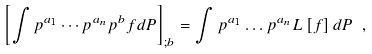<formula> <loc_0><loc_0><loc_500><loc_500>\left [ \int p ^ { a _ { 1 } } \cdots p ^ { a _ { n } } p ^ { b } f d P \right ] _ { ; b } = \int p ^ { a _ { 1 } } \dots p ^ { a _ { n } } L \left [ f \right ] d P \ ,</formula> 